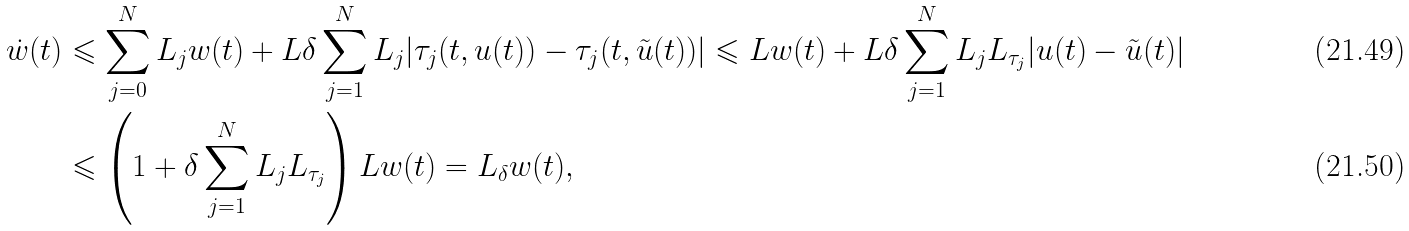<formula> <loc_0><loc_0><loc_500><loc_500>\dot { w } ( t ) & \leqslant \sum _ { j = 0 } ^ { N } L _ { j } w ( t ) + L \delta \sum _ { j = 1 } ^ { N } L _ { j } | \tau _ { j } ( t , u ( t ) ) - \tau _ { j } ( t , \tilde { u } ( t ) ) | \leqslant L w ( t ) + L \delta \sum _ { j = 1 } ^ { N } L _ { j } L _ { \tau _ { j } } | u ( t ) - \tilde { u } ( t ) | \\ & \leqslant \left ( 1 + \delta \sum _ { j = 1 } ^ { N } L _ { j } L _ { \tau _ { j } } \right ) L w ( t ) = L _ { \delta } w ( t ) ,</formula> 